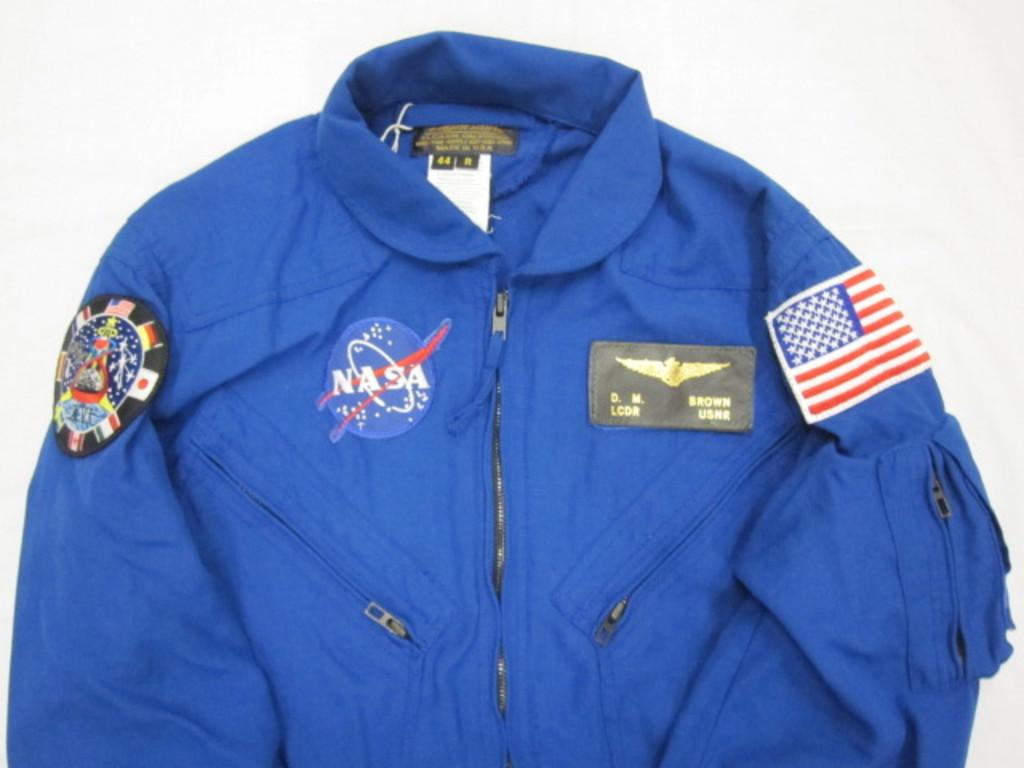What does his wings patch say?
Provide a succinct answer. D.m. brown lcdr usnr. 